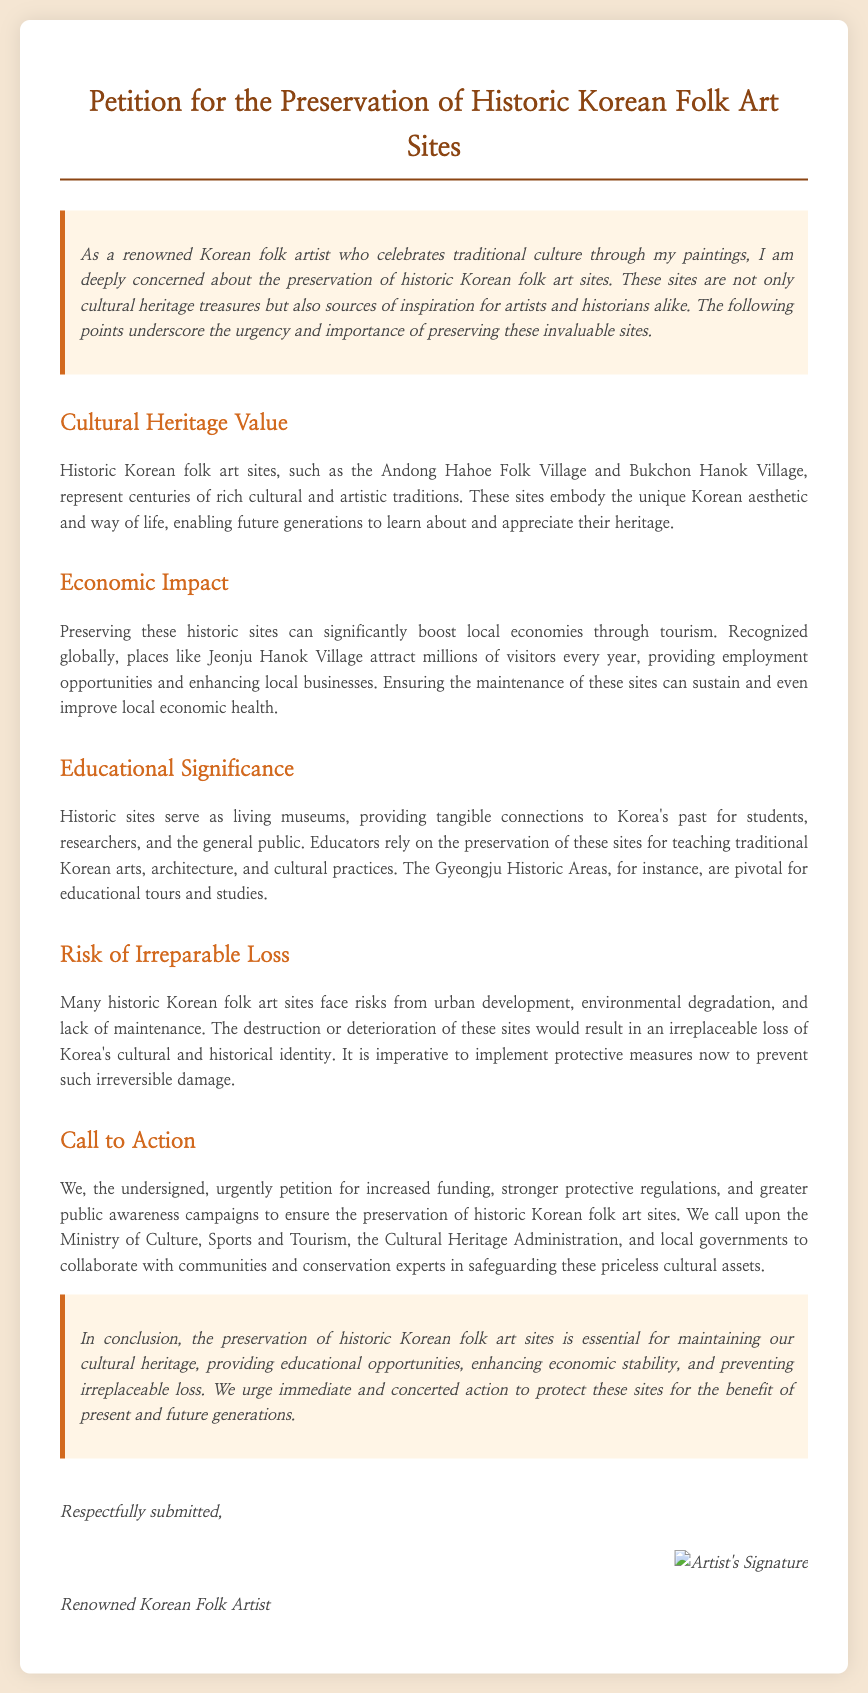what is the title of the petition? The title of the petition is stated at the top of the document and is "Petition for the Preservation of Historic Korean Folk Art Sites."
Answer: Petition for the Preservation of Historic Korean Folk Art Sites which folk village is mentioned as a historic site? The document mentions the Andong Hahoe Folk Village as a historic site representing Korean culture.
Answer: Andong Hahoe Folk Village what is one economic benefit of preserving historic sites? The document states that preserving historic sites can boost local economies through tourism, which provides employment opportunities.
Answer: tourism who is urged to take action in the petition? The petition calls upon the Ministry of Culture, Sports and Tourism, the Cultural Heritage Administration, and local governments to act.
Answer: Ministry of Culture, Sports and Tourism what are historic sites referred to in relation to education? The document refers to historic sites as "living museums," which provide connections to Korea's past.
Answer: living museums what is a significant risk facing historic sites? The document notes that many historic Korean folk art sites face risks from urban development.
Answer: urban development how does the petition conclude? The conclusion emphasizes the importance of preserving historic sites for cultural heritage and urges immediate action to protect them.
Answer: essential for maintaining our cultural heritage what type of document is this? This document is a signed petition aimed at advocating for the preservation of historic sites in Korea.
Answer: signed petition 